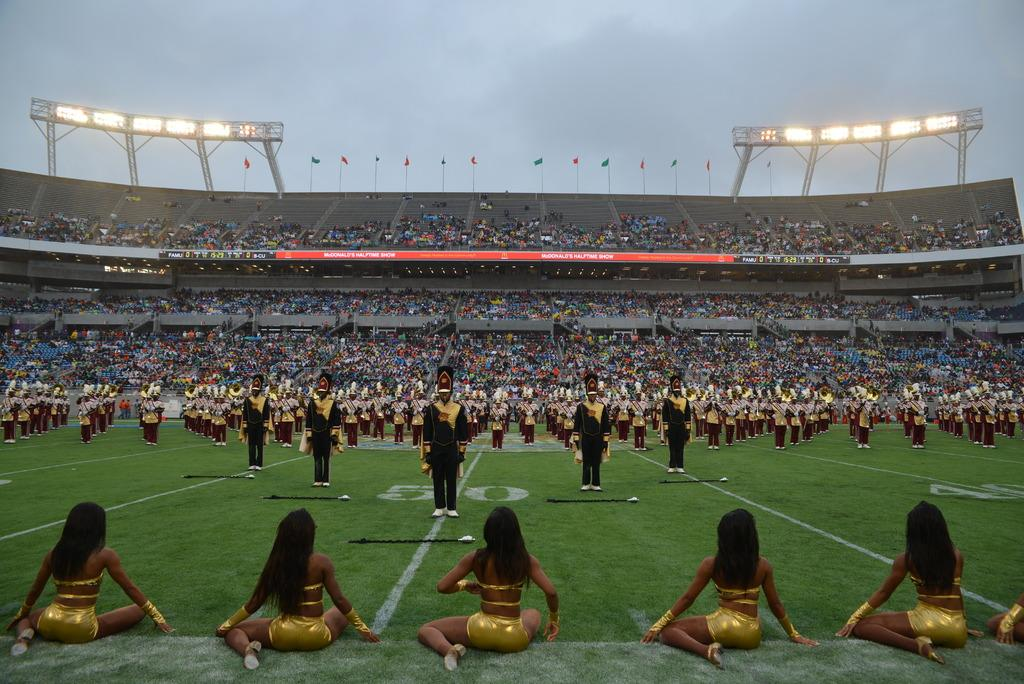How many people are in the image? There is a group of people in the image, but the exact number is not specified. What are the people in the image doing? Some people are standing, while others are sitting. What can be seen in the background of the image? There are red-colored boards, multi-colored flags, and lights visible in the background. What is the color of the sky in the image? The sky appears to be white in color. What type of note is being passed between the people in the image? There is no indication in the image that people are passing notes or engaging in any such activity. 